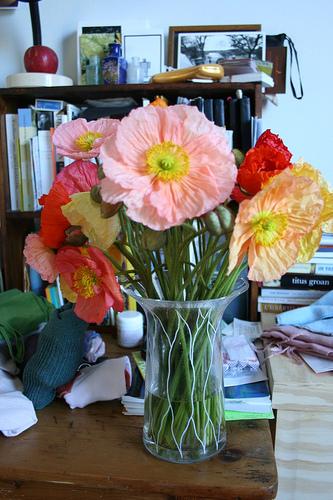What color is the flower in the center?
Keep it brief. Pink. What are the flowers in?
Give a very brief answer. Vase. Why are there socks on the table?
Keep it brief. Laundry. 